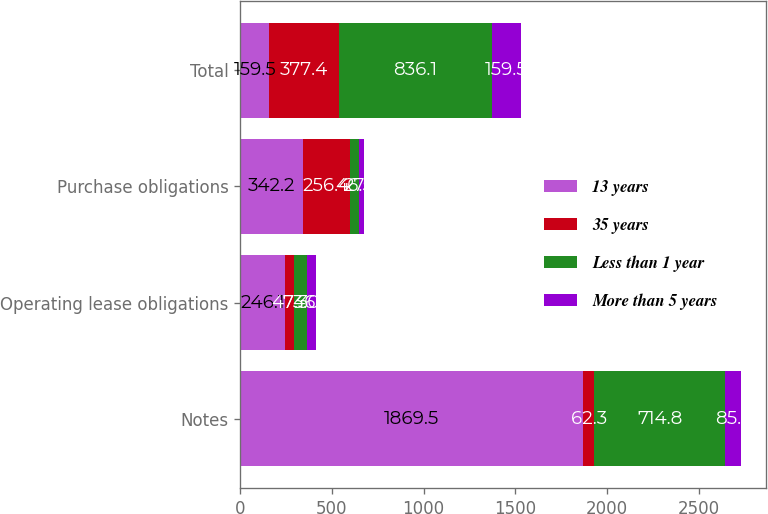Convert chart. <chart><loc_0><loc_0><loc_500><loc_500><stacked_bar_chart><ecel><fcel>Notes<fcel>Operating lease obligations<fcel>Purchase obligations<fcel>Total<nl><fcel>13 years<fcel>1869.5<fcel>246.1<fcel>342.2<fcel>159.5<nl><fcel>35 years<fcel>62.3<fcel>47.3<fcel>256.4<fcel>377.4<nl><fcel>Less than 1 year<fcel>714.8<fcel>73<fcel>46.5<fcel>836.1<nl><fcel>More than 5 years<fcel>85.5<fcel>46.7<fcel>27.3<fcel>159.5<nl></chart> 